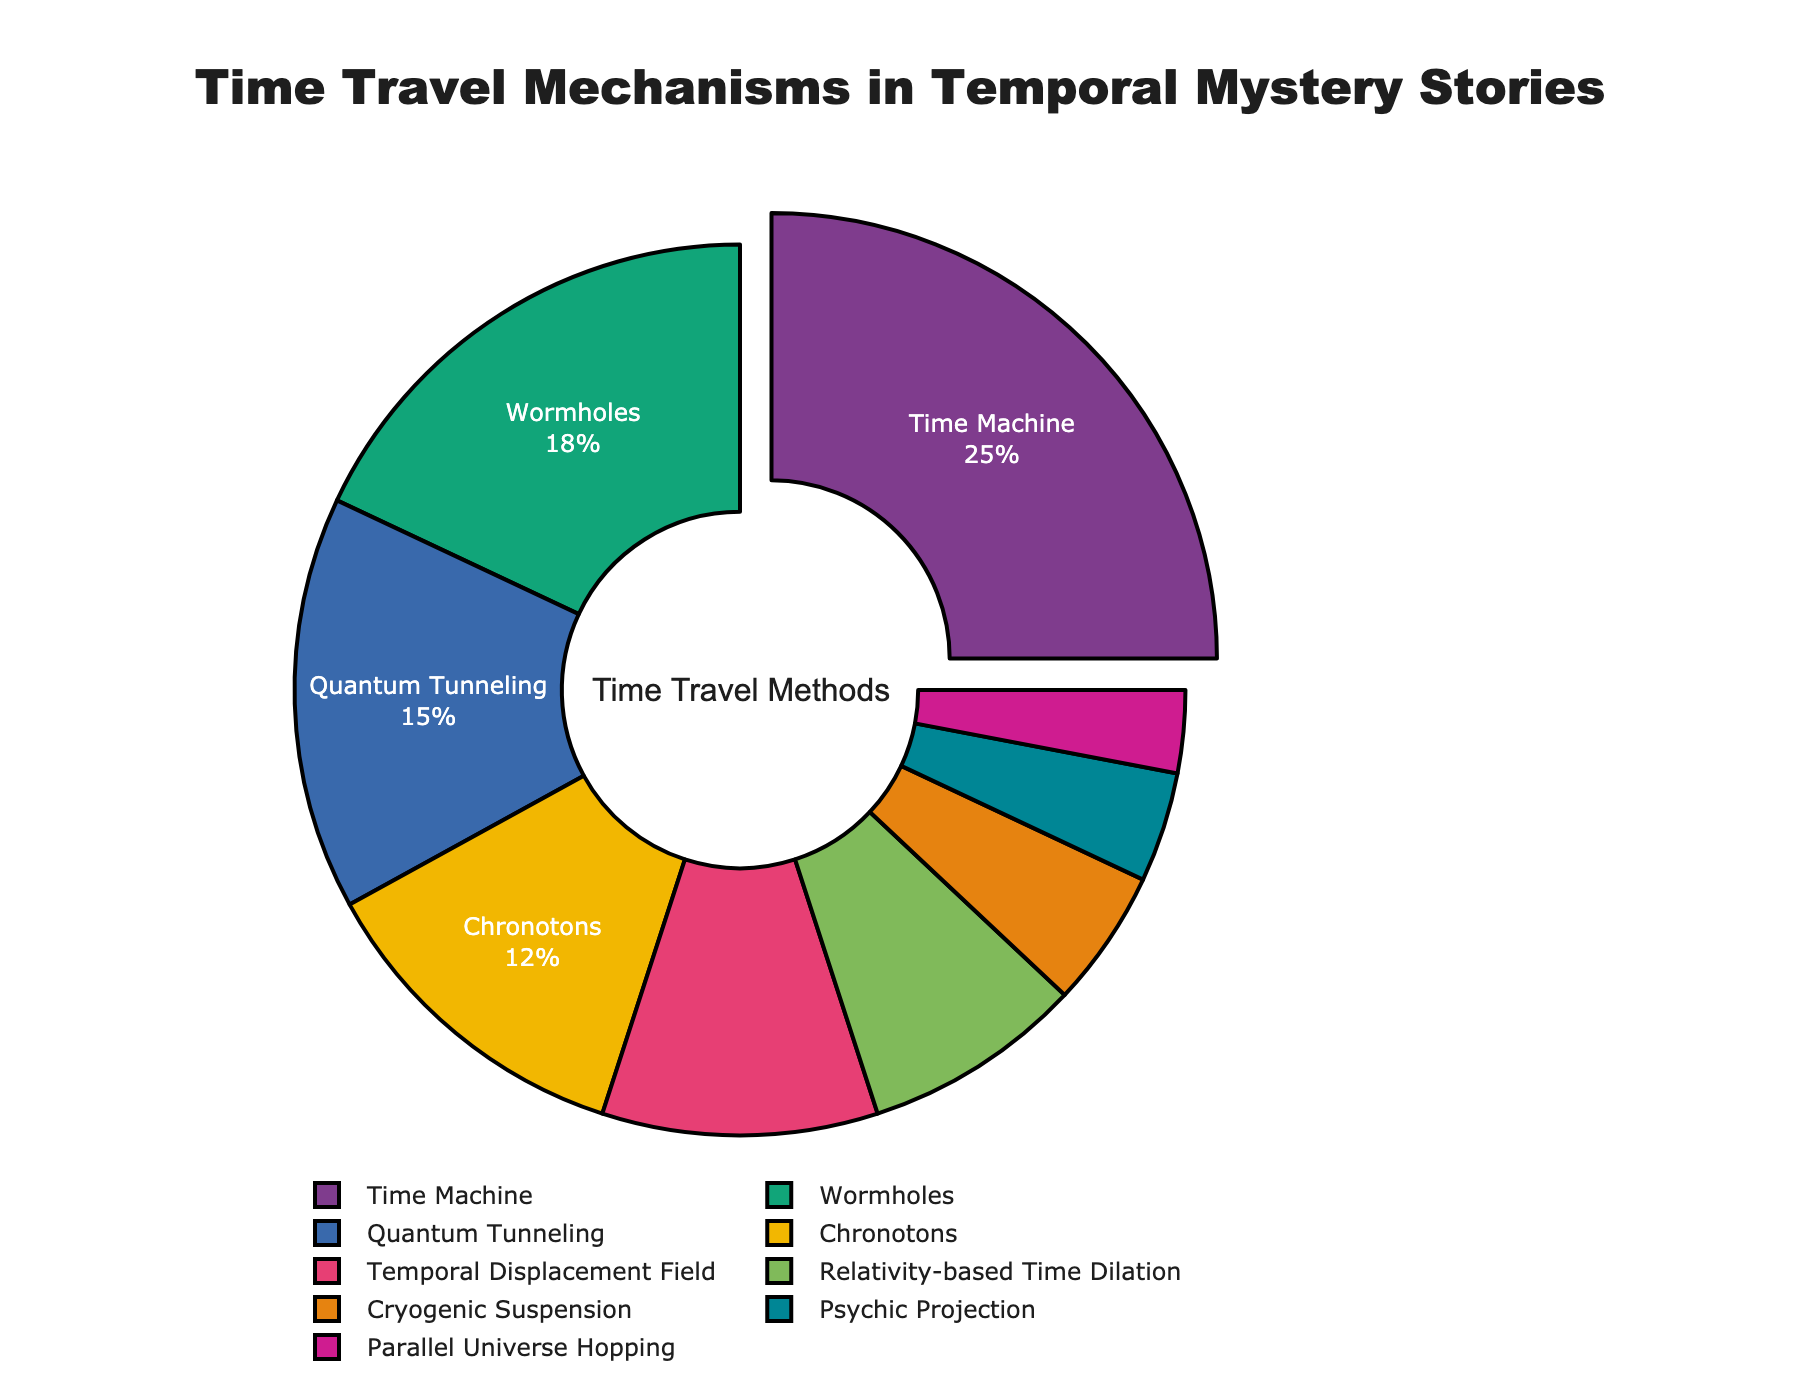What is the most commonly used time travel mechanism in temporal mystery stories? The plot shows that the segment representing the "Time Machine" is pulled out and it has the highest percentage. This indicates that the Time Machine is the most commonly used time travel mechanism.
Answer: Time Machine Which time travel mechanism is used less often: Wormholes or Quantum Tunneling? By comparing the segments, Wormholes have 18% and Quantum Tunneling has 15%, so Quantum Tunneling is used less often.
Answer: Quantum Tunneling What is the combined percentage of Chronotons and Temporal Displacement Field methods? Chronotons represents 12% and Temporal Displacement Field represents 10%. Adding these together (12 + 10) gives a combined percentage of 22%.
Answer: 22% Are there any time travel mechanisms that have a lower proportion than Relativity-based Time Dilation? If so, name them. Relativity-based Time Dilation is 8%. The segments with lower percentages are Cryogenic Suspension (5%), Psychic Projection (4%), and Parallel Universe Hopping (3%).
Answer: Cryogenic Suspension, Psychic Projection, Parallel Universe Hopping What is the difference in percentage between the top two time travel mechanisms? The top two segments are Time Machine (25%) and Wormholes (18%). The difference is 25 - 18 = 7%.
Answer: 7% How many categories have a proportion of less than 10%? Visually checking the segments, Temporal Displacement Field (10%) and all categories below it: Relativity-based Time Dilation (8%), Cryogenic Suspension (5%), Psychic Projection (4%), and Parallel Universe Hopping (3%) qualify. That is 5 categories.
Answer: 5 Which time travel mechanism has the least representation in temporal mystery stories? The smallest segment with the least percentage is Parallel Universe Hopping, with 3%.
Answer: Parallel Universe Hopping If you combined the percentages of all the methods except Time Machine, would it exceed 50%? The percentage for Time Machine is 25%. Adding up all other percentages: 18 (Wormholes), 15 (Quantum Tunneling), 12 (Chronotons), 10 (Temporal Displacement Field), 8 (Relativity-based Time Dilation), 5 (Cryogenic Suspension), 4 (Psychic Projection), 3 (Parallel Universe Hopping), gives 75%. Therefore, yes, the combined percentage exceeds 50%.
Answer: Yes, 75% What is the total percentage represented by Quantum Tunneling, Temporal Displacement Field, and Relativity-based Time Dilation combined? Quantum Tunneling (15%), Temporal Displacement Field (10%), and Relativity-based Time Dilation (8%). Combining these, 15+10+8 = 33%.
Answer: 33% Based on the visual representation, how is the most used time travel method indicated differently in the pie chart compared to the others? The segment representing the most common method, Time Machine, is pulled out from the rest of the pie, indicating it has the largest percentage.
Answer: It is pulled out 